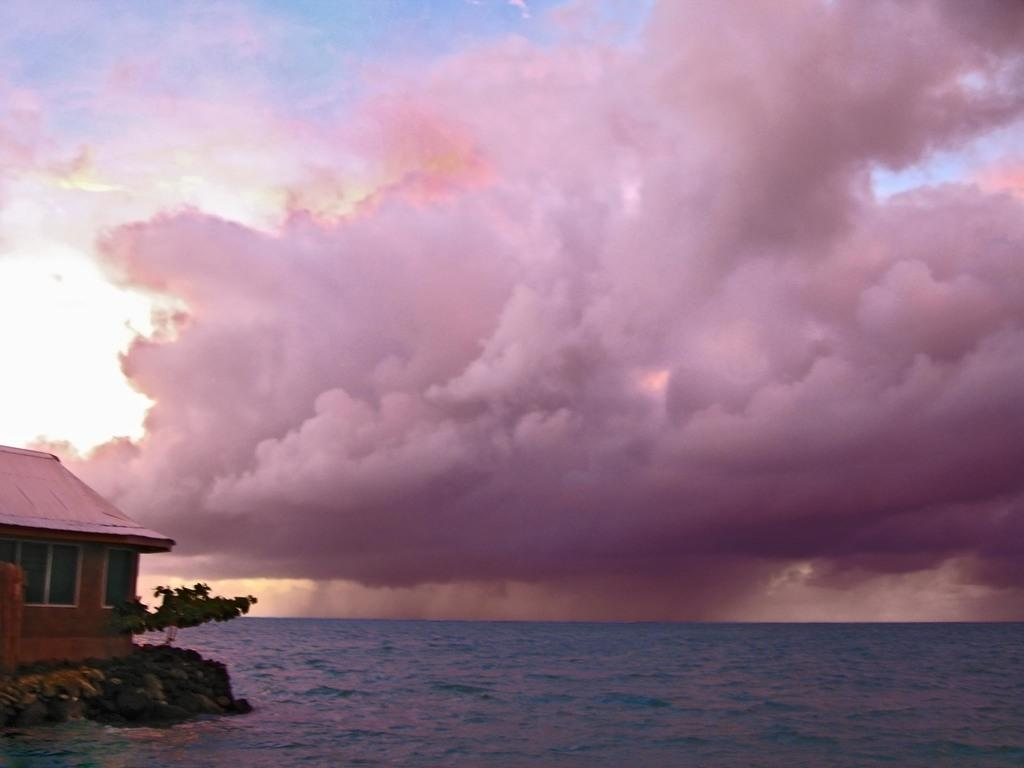What type of structure is present in the image? There is a house in the image. What natural elements can be seen near the water in the image? There is a tree beside the water in the image. What can be observed in the sky in the background of the image? There are clouds visible in the background of the image. What type of quince attraction can be seen near the beef in the image? There is no quince attraction or beef present in the image. 